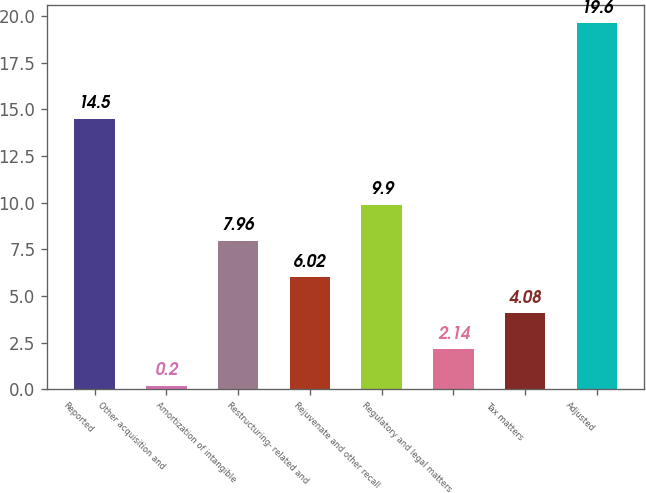Convert chart to OTSL. <chart><loc_0><loc_0><loc_500><loc_500><bar_chart><fcel>Reported<fcel>Other acquisition and<fcel>Amortization of intangible<fcel>Restructuring- related and<fcel>Rejuvenate and other recall<fcel>Regulatory and legal matters<fcel>Tax matters<fcel>Adjusted<nl><fcel>14.5<fcel>0.2<fcel>7.96<fcel>6.02<fcel>9.9<fcel>2.14<fcel>4.08<fcel>19.6<nl></chart> 